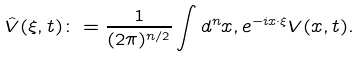<formula> <loc_0><loc_0><loc_500><loc_500>\hat { V } ( \xi , t ) \colon = \frac { 1 } { ( 2 \pi ) ^ { n / 2 } } \int d ^ { n } x , e ^ { - i x \cdot \xi } V ( x , t ) .</formula> 